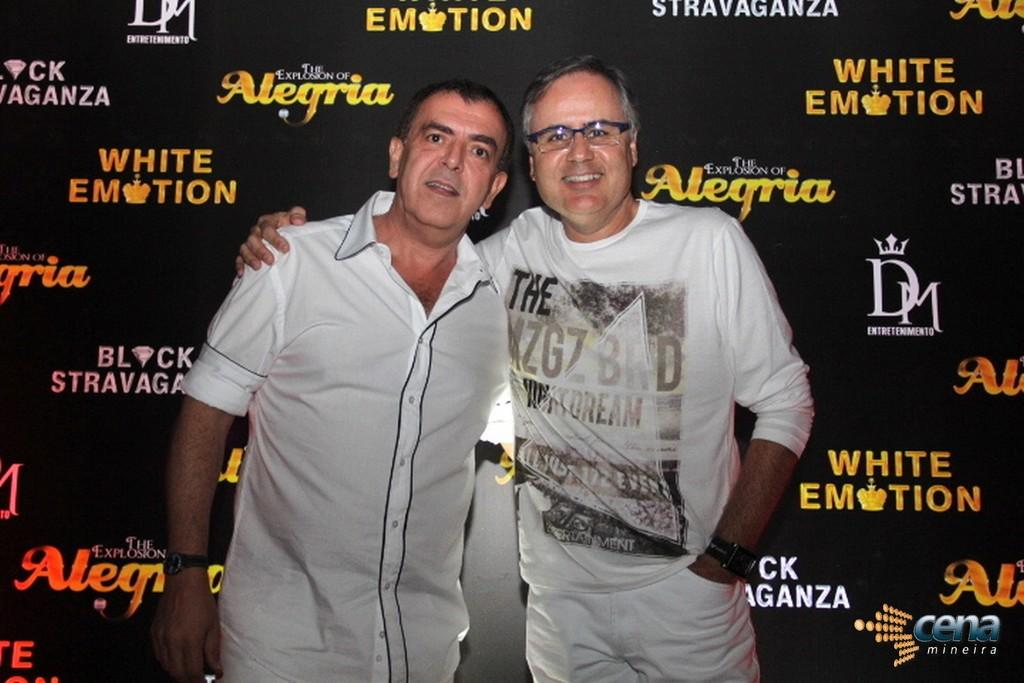How many people are present in the image? There are two persons standing in the image. What is the facial expression of the persons in the image? The persons are smiling. What can be seen in the background of the image? There is a board in the background of the image. Is there any additional information about the image itself? Yes, there is a watermark on the image. What type of thing is being ordered by the persons in the image? There is no indication in the image that the persons are ordering anything, so it cannot be determined from the picture. 